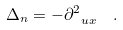Convert formula to latex. <formula><loc_0><loc_0><loc_500><loc_500>\Delta _ { n } = - \partial _ { \ u x } ^ { 2 } \ \ .</formula> 